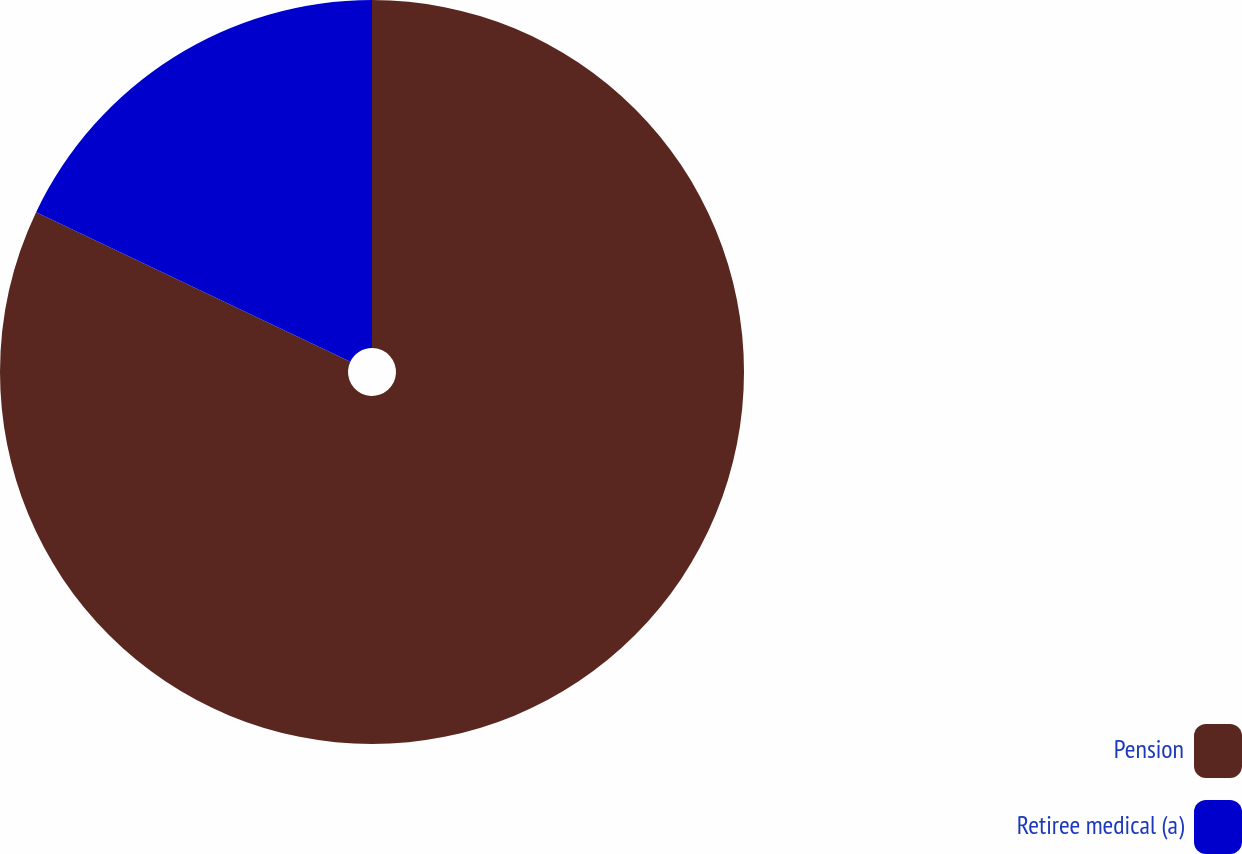<chart> <loc_0><loc_0><loc_500><loc_500><pie_chart><fcel>Pension<fcel>Retiree medical (a)<nl><fcel>82.07%<fcel>17.93%<nl></chart> 